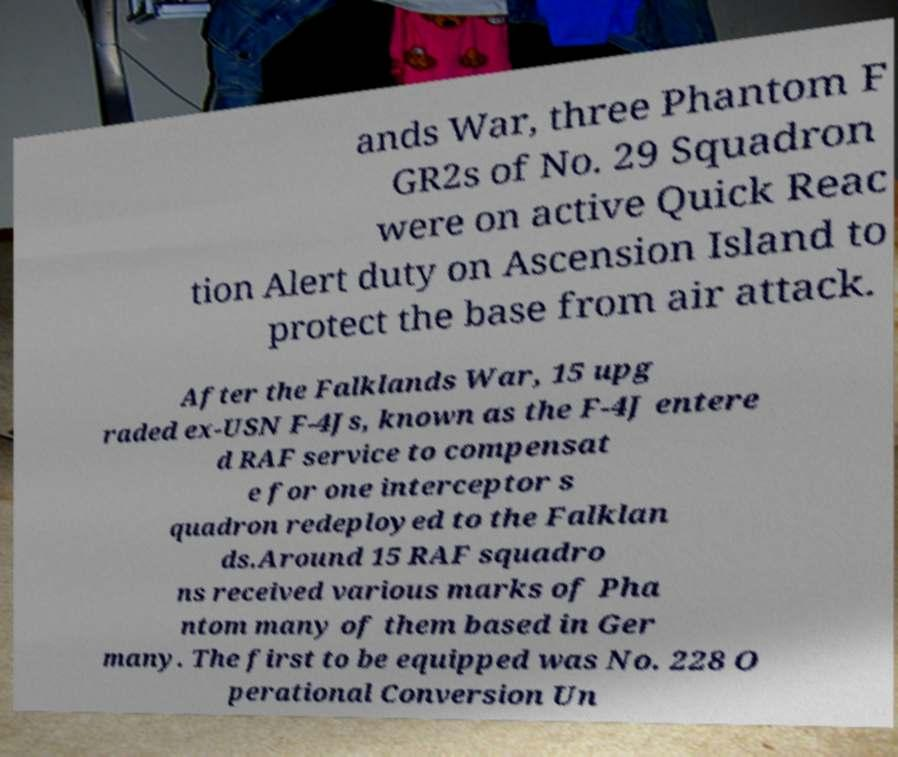What messages or text are displayed in this image? I need them in a readable, typed format. ands War, three Phantom F GR2s of No. 29 Squadron were on active Quick Reac tion Alert duty on Ascension Island to protect the base from air attack. After the Falklands War, 15 upg raded ex-USN F-4Js, known as the F-4J entere d RAF service to compensat e for one interceptor s quadron redeployed to the Falklan ds.Around 15 RAF squadro ns received various marks of Pha ntom many of them based in Ger many. The first to be equipped was No. 228 O perational Conversion Un 